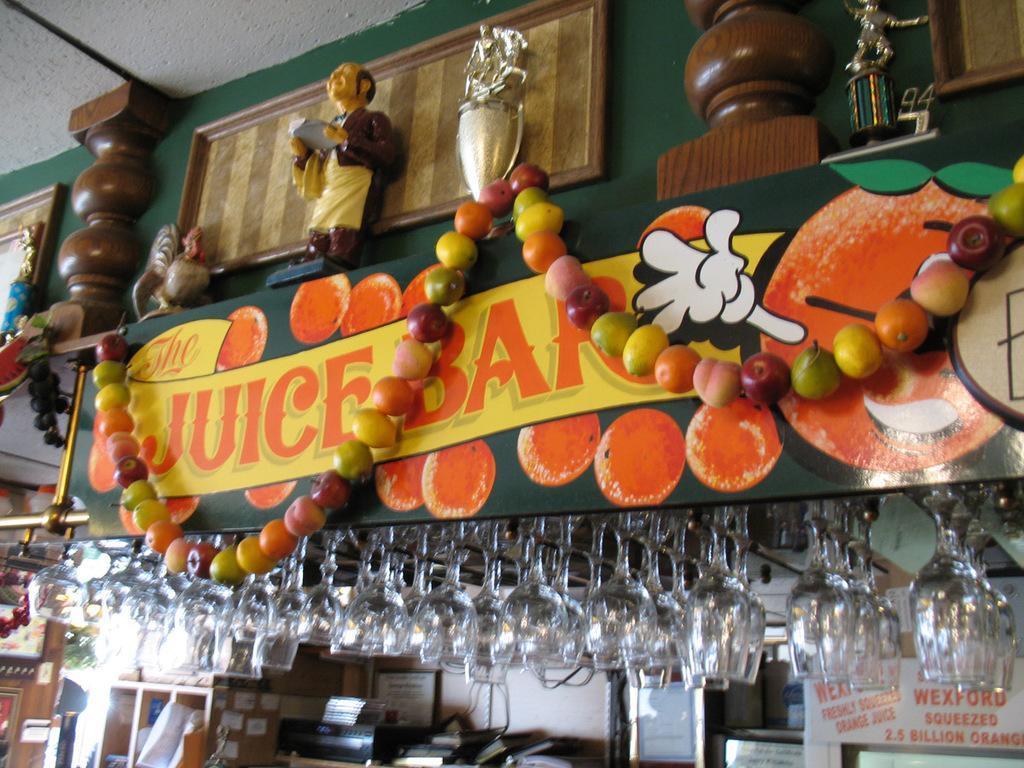Please provide a concise description of this image. In this image, we can see the store. Here there are so many glasses are hanging. At the bottom, we can see few things and objects. Here there is a hoarding decoration with fruits garland. Top of the image, we can see few sculptures. On the left side top corner, we can see the ceiling. 